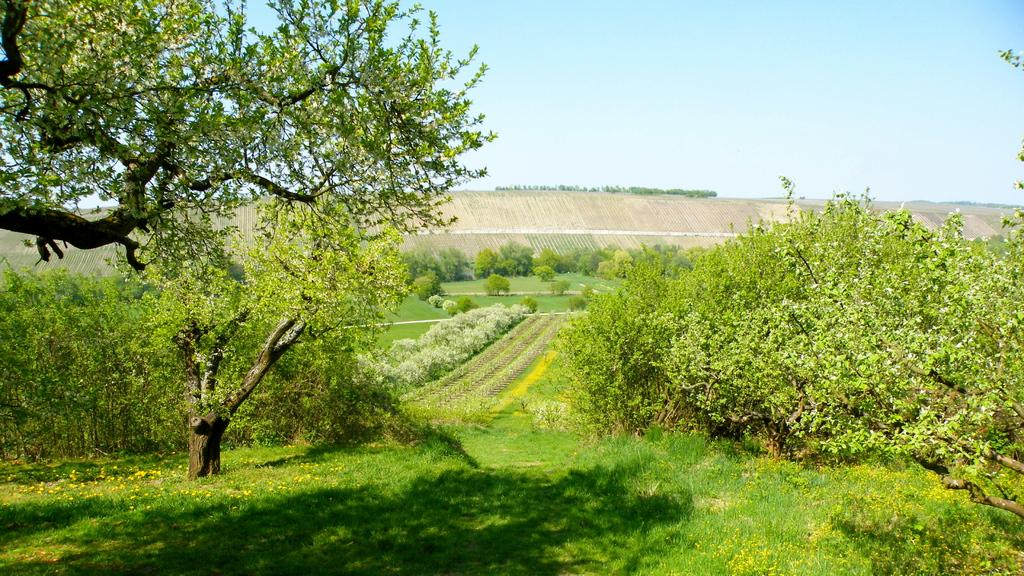What type of vegetation can be seen in the image? There is grass and trees in the image. Can you describe the natural environment depicted in the image? The image features grass and trees, which suggests a natural setting. What type of corn can be seen growing in the image? There is no corn present in the image; it only features grass and trees. What color is the ink used to write on the trees in the image? There is no writing or ink present on the trees in the image. 